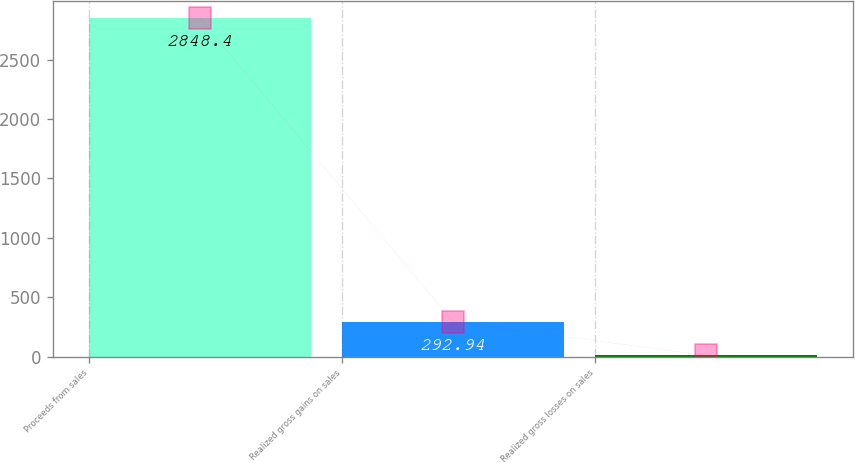Convert chart to OTSL. <chart><loc_0><loc_0><loc_500><loc_500><bar_chart><fcel>Proceeds from sales<fcel>Realized gross gains on sales<fcel>Realized gross losses on sales<nl><fcel>2848.4<fcel>292.94<fcel>9<nl></chart> 